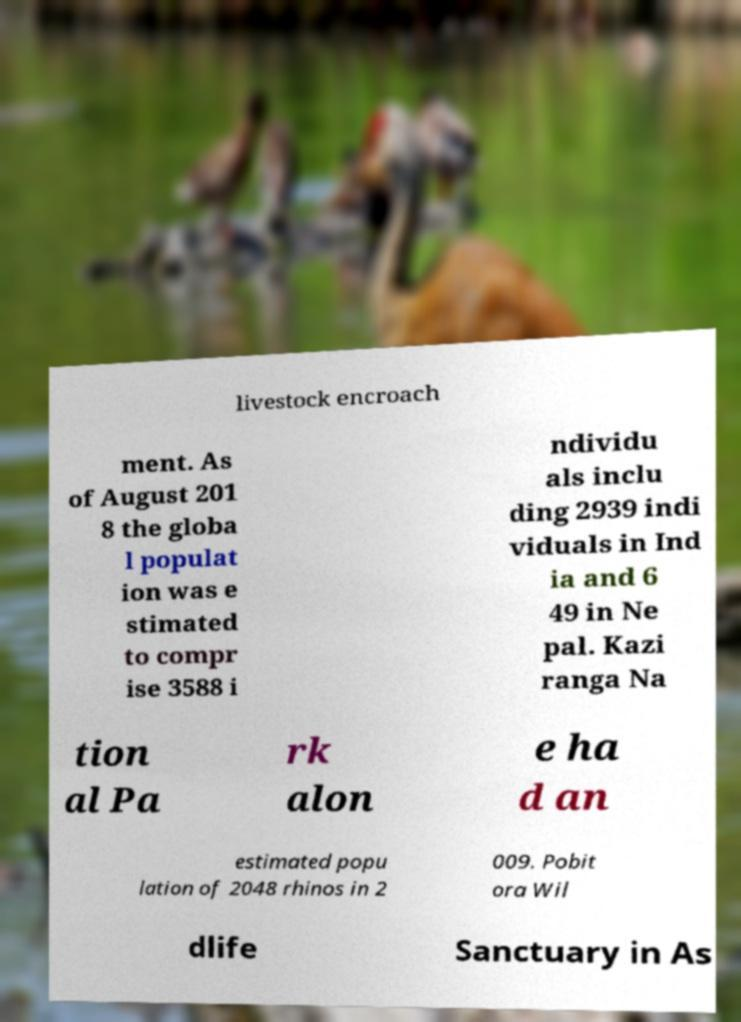Could you assist in decoding the text presented in this image and type it out clearly? livestock encroach ment. As of August 201 8 the globa l populat ion was e stimated to compr ise 3588 i ndividu als inclu ding 2939 indi viduals in Ind ia and 6 49 in Ne pal. Kazi ranga Na tion al Pa rk alon e ha d an estimated popu lation of 2048 rhinos in 2 009. Pobit ora Wil dlife Sanctuary in As 